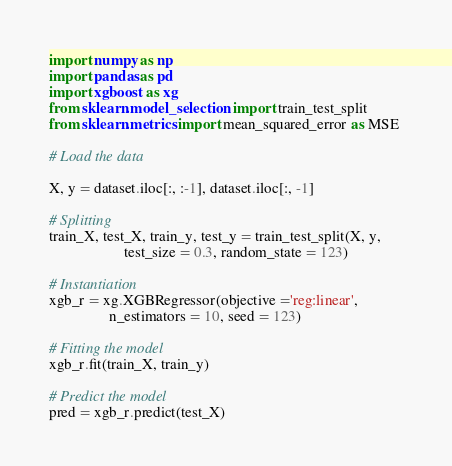Convert code to text. <code><loc_0><loc_0><loc_500><loc_500><_Python_>import numpy as np 
import pandas as pd 
import xgboost as xg 
from sklearn.model_selection import train_test_split 
from sklearn.metrics import mean_squared_error as MSE 

# Load the data 

X, y = dataset.iloc[:, :-1], dataset.iloc[:, -1] 

# Splitting 
train_X, test_X, train_y, test_y = train_test_split(X, y, 
					test_size = 0.3, random_state = 123) 

# Instantiation 
xgb_r = xg.XGBRegressor(objective ='reg:linear', 
				n_estimators = 10, seed = 123) 

# Fitting the model 
xgb_r.fit(train_X, train_y) 

# Predict the model 
pred = xgb_r.predict(test_X) 
</code> 